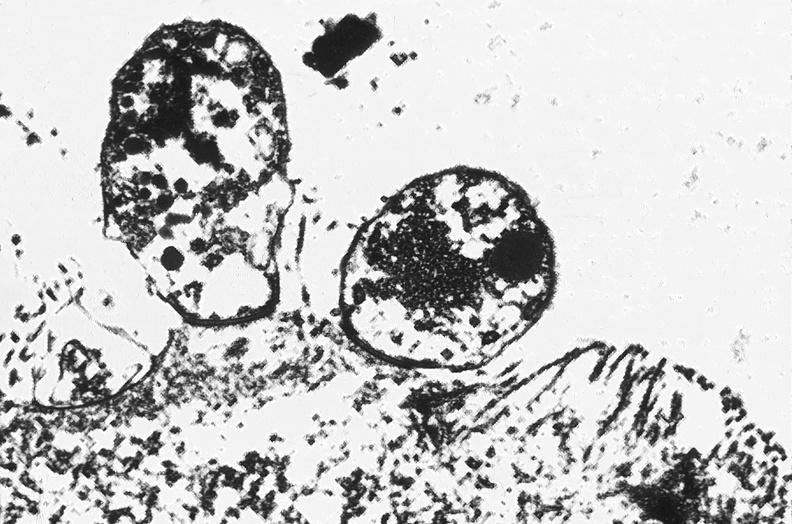where is this electron microscopy figure taken?
Answer the question using a single word or phrase. Gastrointestinal system 